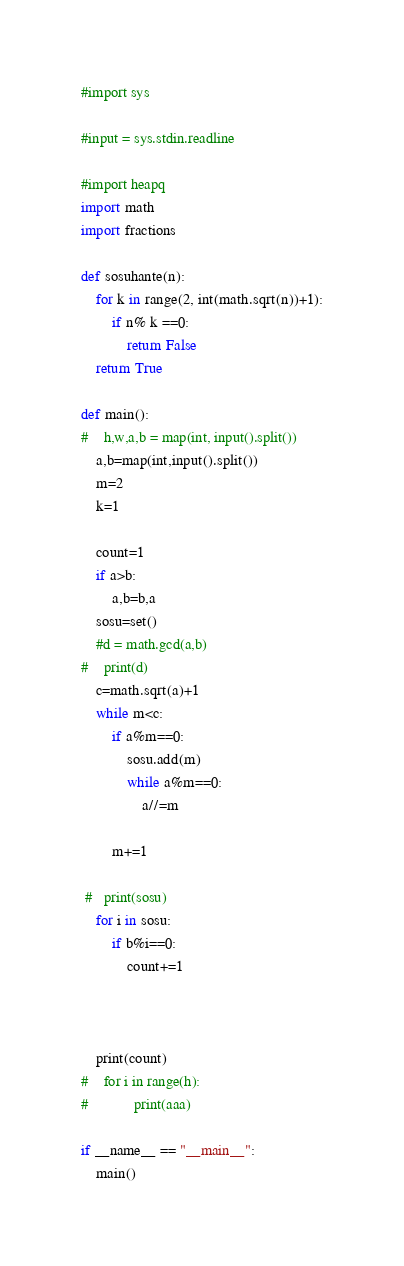Convert code to text. <code><loc_0><loc_0><loc_500><loc_500><_Python_>#import sys

#input = sys.stdin.readline

#import heapq
import math
import fractions

def sosuhante(n):
    for k in range(2, int(math.sqrt(n))+1):
        if n% k ==0:
            return False
    return True

def main():
#    h,w,a,b = map(int, input().split())
    a,b=map(int,input().split())
    m=2
    k=1

    count=1
    if a>b:
        a,b=b,a
    sosu=set()
    #d = math.gcd(a,b)
#    print(d)
    c=math.sqrt(a)+1
    while m<c:
        if a%m==0:
            sosu.add(m)
            while a%m==0:
                a//=m

        m+=1

 #   print(sosu)
    for i in sosu:
        if b%i==0:
            count+=1



    print(count)
#    for i in range(h):
#            print(aaa)

if __name__ == "__main__":
    main()</code> 